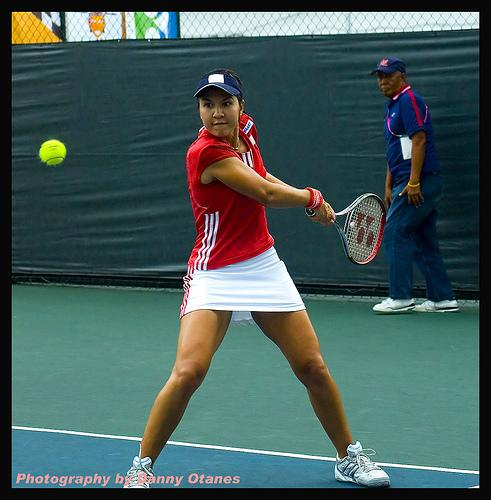The ball used in badminton is made up of what? rubber 